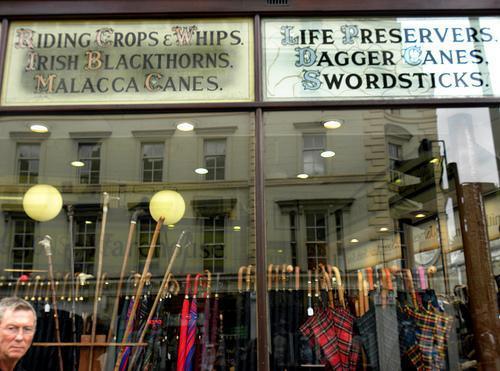How many people are in the photo?
Give a very brief answer. 1. How many yellow round lights are in the photo?
Give a very brief answer. 2. 